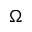<formula> <loc_0><loc_0><loc_500><loc_500>\Omega</formula> 